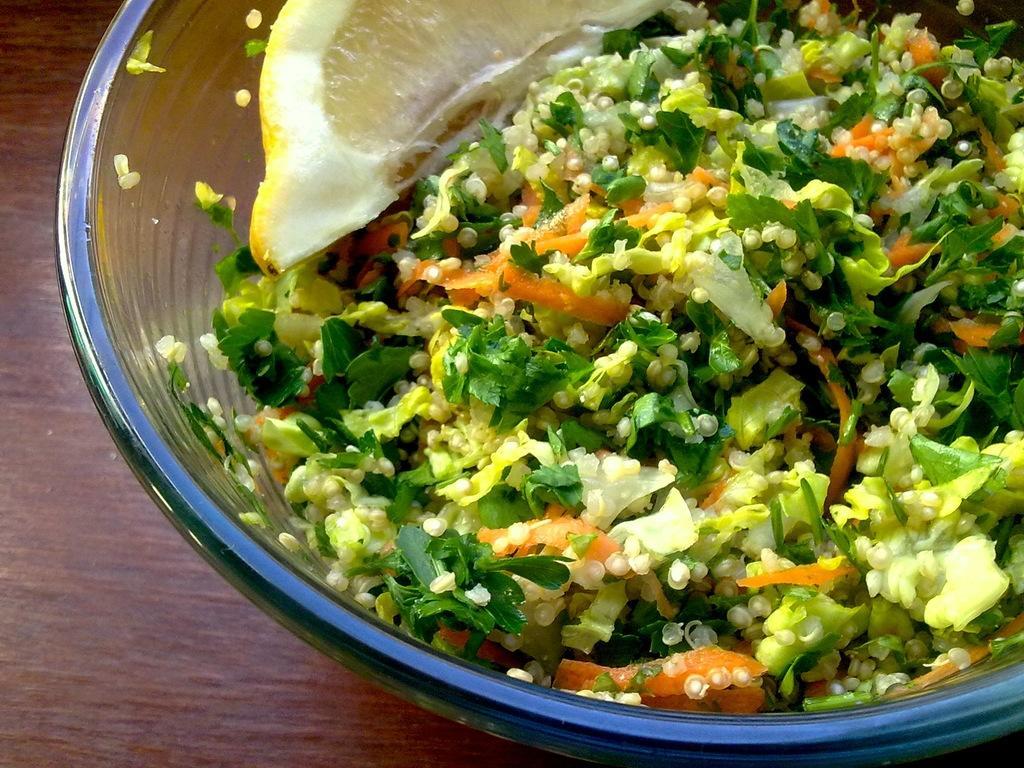Could you give a brief overview of what you see in this image? In this image I can see a food item in glass bowl. Food is in white,yellow,green and orange color. The bowl is on the brown color table. 